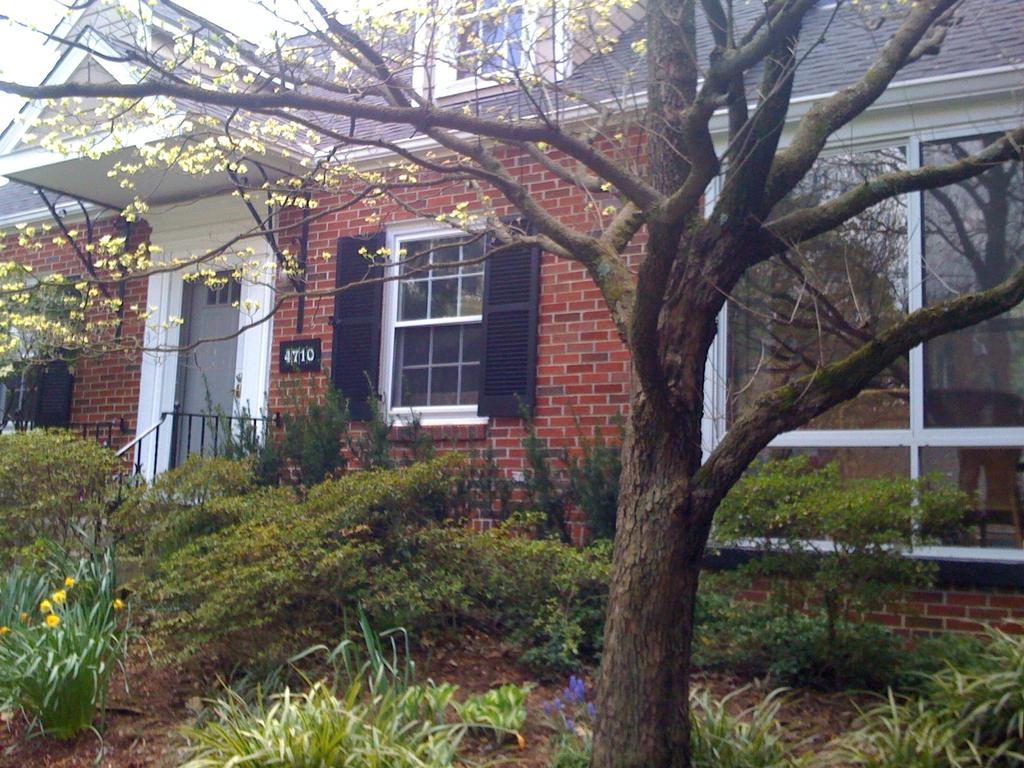What is the main structure in the picture? There is a house in the picture. What can be seen in front of the house? There are many plants and trees in front of the house. How many snakes are wrapped around the house in the image? There are no snakes present in the image. What type of scarecrow can be seen standing among the plants in the image? There is no scarecrow present in the image. 